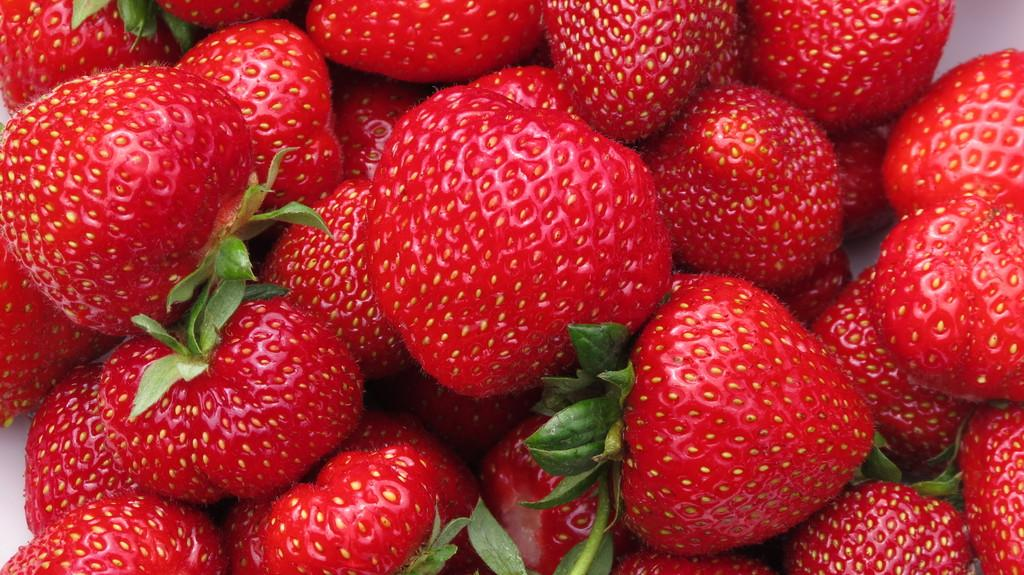What type of fruit is visible in the image? There are red-colored strawberries in the image. What is the reaction of the strawberries to the plot in the image? There is no plot or reaction present in the image, as it only features strawberries. 